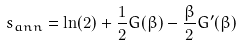<formula> <loc_0><loc_0><loc_500><loc_500>s _ { a n n } = \ln ( 2 ) + \frac { 1 } { 2 } G ( \beta ) - \frac { \beta } { 2 } G ^ { \prime } ( \beta )</formula> 